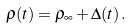<formula> <loc_0><loc_0><loc_500><loc_500>\varrho ( t ) = \varrho _ { \infty } + \Delta ( t ) \, .</formula> 